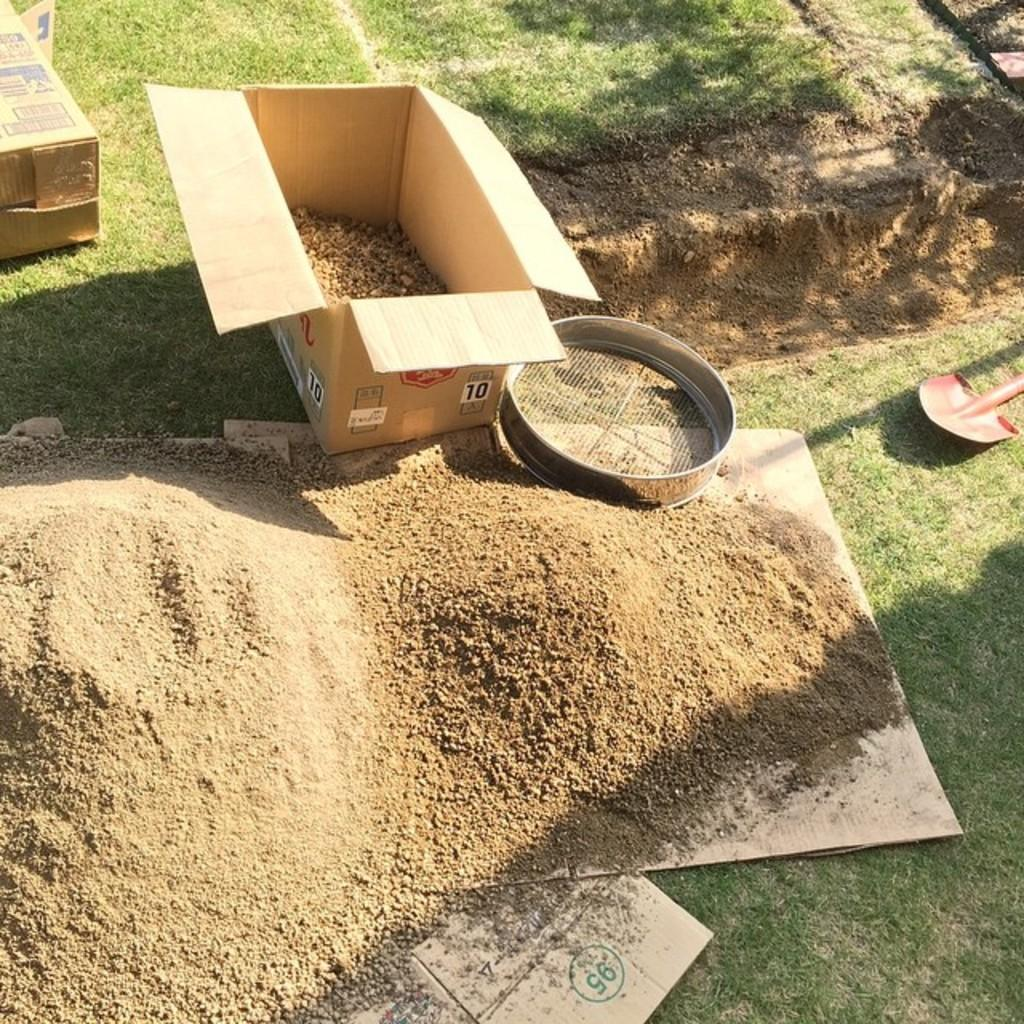What type of surface is visible in the image? There is sand in the image. What material is present in the image besides sand? There is cardboard and a net in the image. What tool is visible in the image? There is a shovel in the image. What type of hate can be seen expressed on the cardboard in the image? There is no hate expressed on the cardboard in the image; it is simply a material present in the scene. 